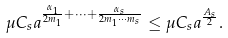<formula> <loc_0><loc_0><loc_500><loc_500>\mu C _ { s } a ^ { \frac { \alpha _ { 1 } } { 2 m _ { 1 } } + \dots + \frac { \alpha _ { s } } { 2 m _ { 1 } \cdots m _ { s } } } \leq \mu C _ { s } a ^ { \frac { A _ { s } } { 2 } } .</formula> 